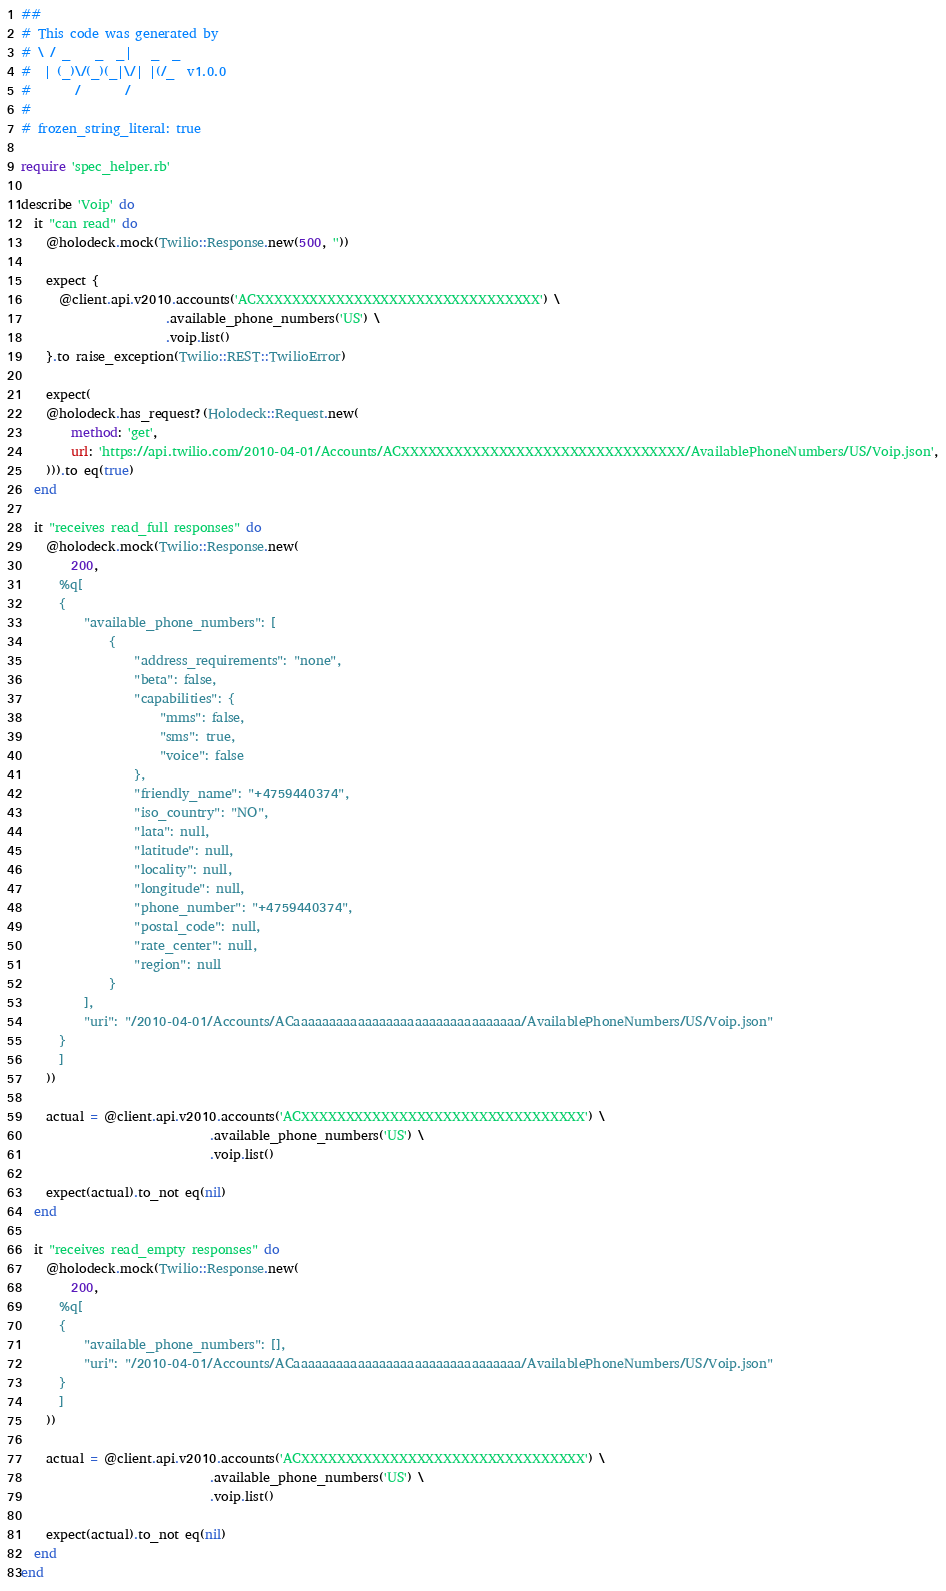Convert code to text. <code><loc_0><loc_0><loc_500><loc_500><_Ruby_>##
# This code was generated by
# \ / _    _  _|   _  _
#  | (_)\/(_)(_|\/| |(/_  v1.0.0
#       /       /
#
# frozen_string_literal: true

require 'spec_helper.rb'

describe 'Voip' do
  it "can read" do
    @holodeck.mock(Twilio::Response.new(500, ''))

    expect {
      @client.api.v2010.accounts('ACXXXXXXXXXXXXXXXXXXXXXXXXXXXXXXXX') \
                       .available_phone_numbers('US') \
                       .voip.list()
    }.to raise_exception(Twilio::REST::TwilioError)

    expect(
    @holodeck.has_request?(Holodeck::Request.new(
        method: 'get',
        url: 'https://api.twilio.com/2010-04-01/Accounts/ACXXXXXXXXXXXXXXXXXXXXXXXXXXXXXXXX/AvailablePhoneNumbers/US/Voip.json',
    ))).to eq(true)
  end

  it "receives read_full responses" do
    @holodeck.mock(Twilio::Response.new(
        200,
      %q[
      {
          "available_phone_numbers": [
              {
                  "address_requirements": "none",
                  "beta": false,
                  "capabilities": {
                      "mms": false,
                      "sms": true,
                      "voice": false
                  },
                  "friendly_name": "+4759440374",
                  "iso_country": "NO",
                  "lata": null,
                  "latitude": null,
                  "locality": null,
                  "longitude": null,
                  "phone_number": "+4759440374",
                  "postal_code": null,
                  "rate_center": null,
                  "region": null
              }
          ],
          "uri": "/2010-04-01/Accounts/ACaaaaaaaaaaaaaaaaaaaaaaaaaaaaaaaa/AvailablePhoneNumbers/US/Voip.json"
      }
      ]
    ))

    actual = @client.api.v2010.accounts('ACXXXXXXXXXXXXXXXXXXXXXXXXXXXXXXXX') \
                              .available_phone_numbers('US') \
                              .voip.list()

    expect(actual).to_not eq(nil)
  end

  it "receives read_empty responses" do
    @holodeck.mock(Twilio::Response.new(
        200,
      %q[
      {
          "available_phone_numbers": [],
          "uri": "/2010-04-01/Accounts/ACaaaaaaaaaaaaaaaaaaaaaaaaaaaaaaaa/AvailablePhoneNumbers/US/Voip.json"
      }
      ]
    ))

    actual = @client.api.v2010.accounts('ACXXXXXXXXXXXXXXXXXXXXXXXXXXXXXXXX') \
                              .available_phone_numbers('US') \
                              .voip.list()

    expect(actual).to_not eq(nil)
  end
end</code> 